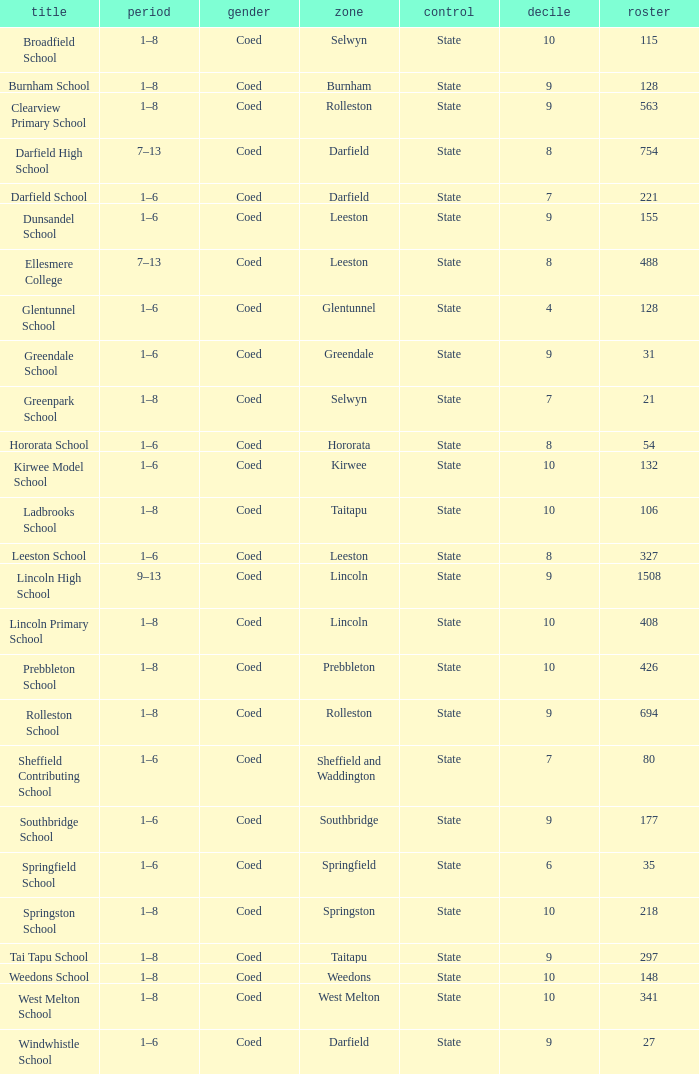Which years have a Name of ladbrooks school? 1–8. 